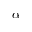<formula> <loc_0><loc_0><loc_500><loc_500>\alpha</formula> 